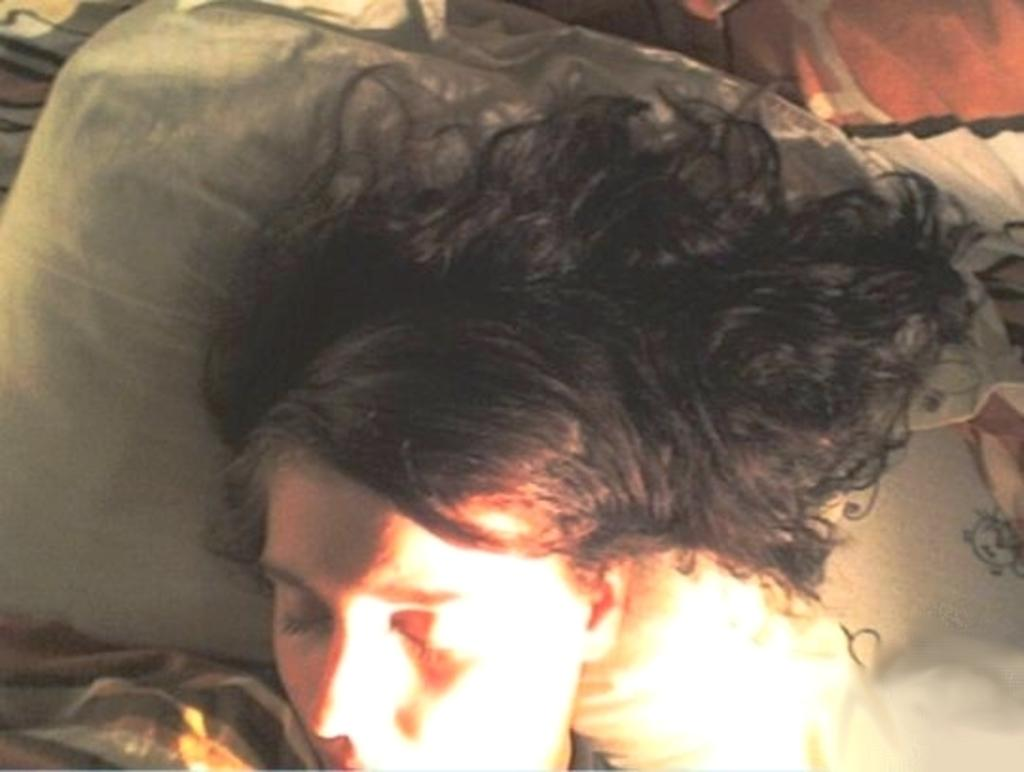What is the person in the image doing? The person is sleeping in the image. What is the person using to support their head while sleeping? The person's head is resting on a pillow. What color is the pillow? The pillow is white in color. What else can be seen in the image besides the person and the pillow? There is a cloth visible in the image. What type of argument is the person having with the cloth in the image? There is no argument present in the image, and the person is sleeping, not interacting with the cloth. 